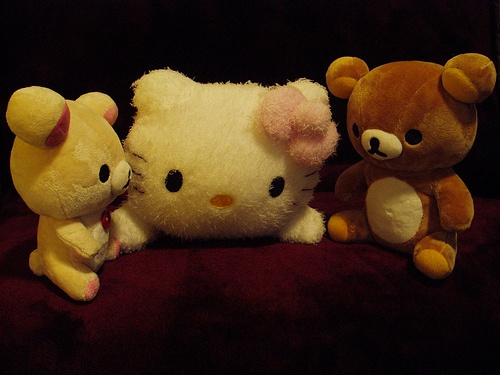Describe the objects in this image and their specific colors. I can see couch in black and maroon tones, teddy bear in black, maroon, and olive tones, and teddy bear in black, olive, maroon, and tan tones in this image. 